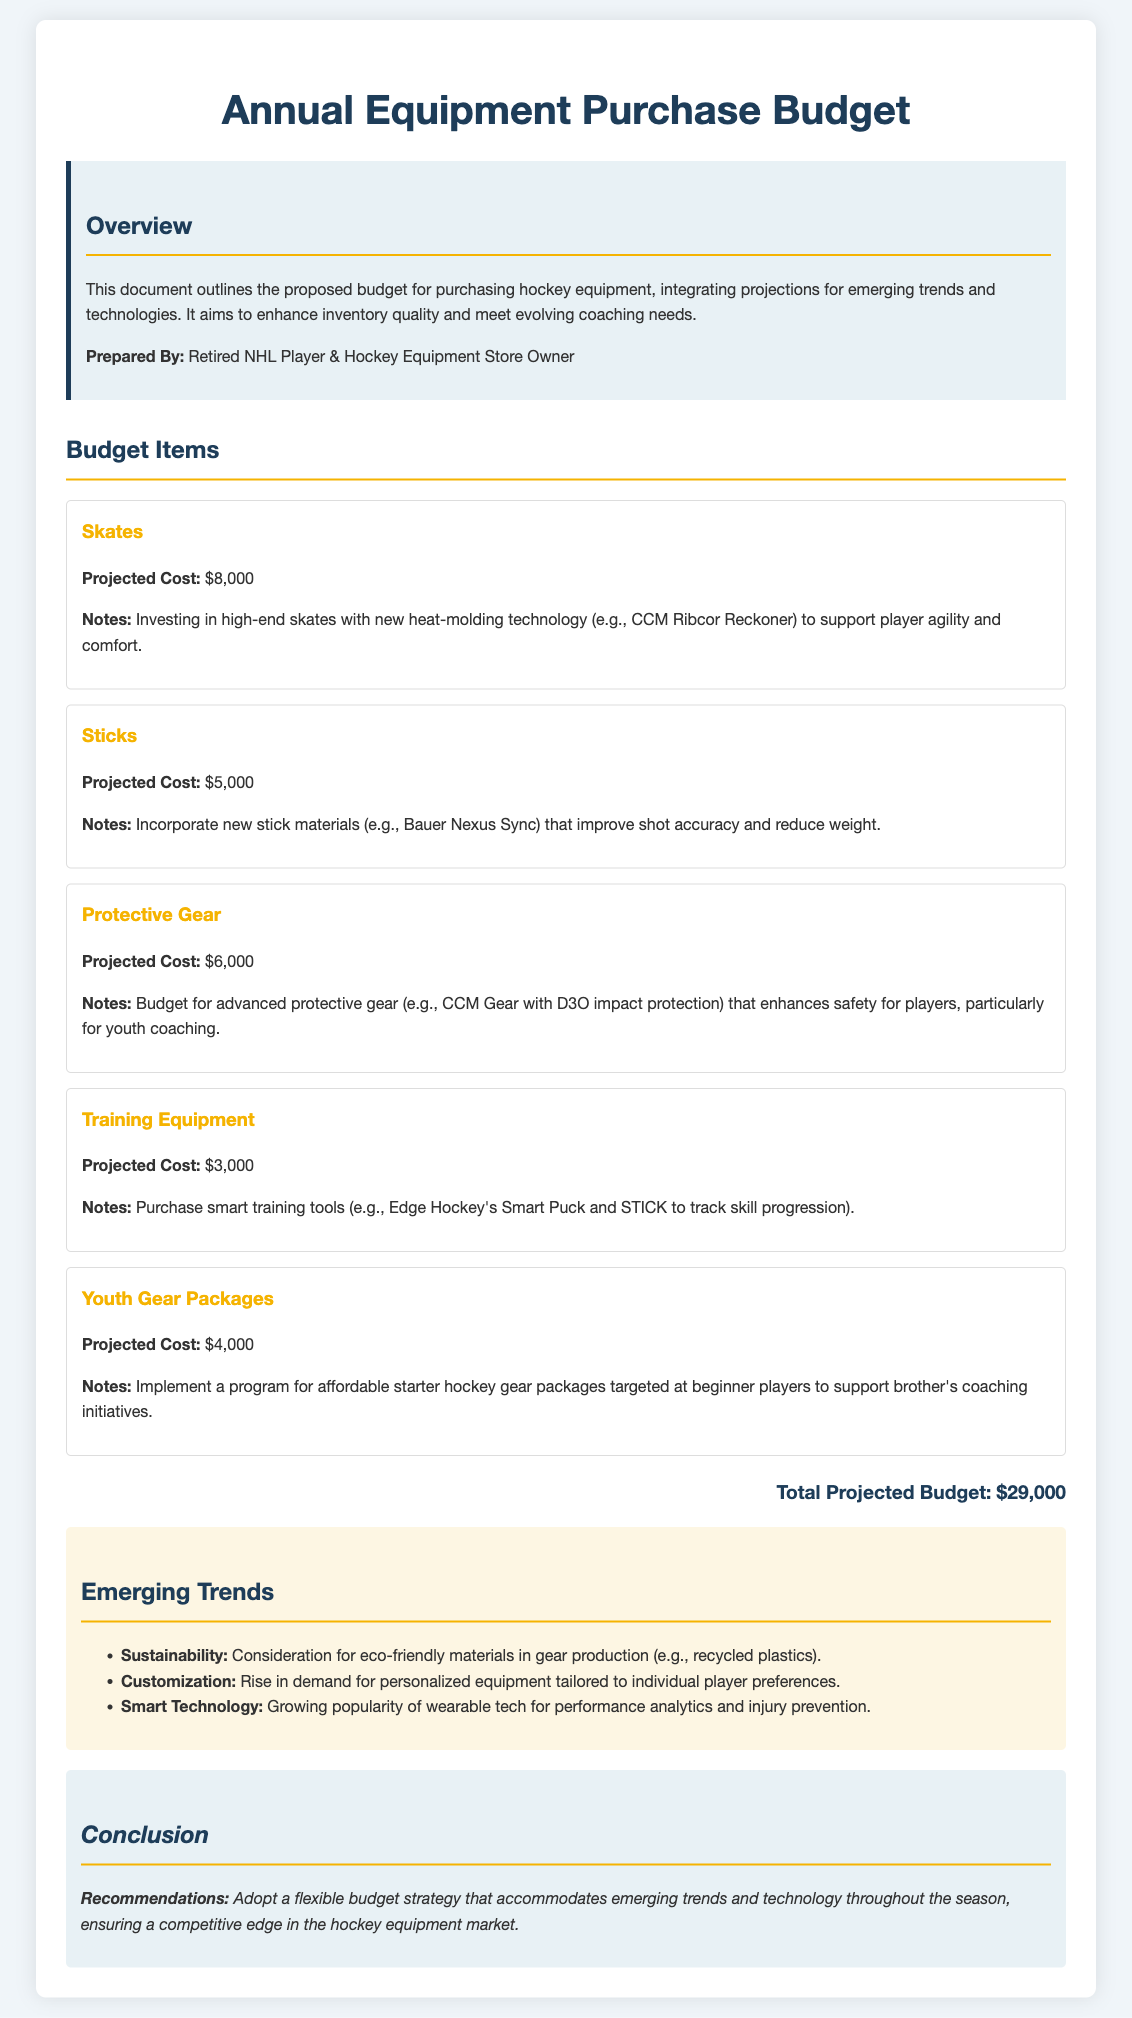What is the total projected budget? The total projected budget is provided at the end of the document, summing all costs of the budget items.
Answer: $29,000 What is the projected cost for skates? The projected cost for skates is listed under the budget items section.
Answer: $8,000 What technology is highlighted for skates? The document mentions a specific type of technology used in skates that enhances player agility and comfort.
Answer: Heat-molding technology Which protective gear feature improves safety? The document lists a specific feature of the protective gear that focuses on increased safety for players.
Answer: D3O impact protection What type of training equipment is mentioned? The document describes a specific training tool that aids in tracking skill progression.
Answer: Smart training tools How much is allocated for youth gear packages? The document specifies the budget set aside for youth gear packages.
Answer: $4,000 What emerging trend relates to materials? The document discusses a consideration for a trend affecting the production of hockey gear.
Answer: Sustainability Which stick is suggested for improving shot accuracy? The document names a specific stick that incorporates new materials.
Answer: Bauer Nexus Sync What recommendation is made regarding budget strategy? The conclusion section suggests a specific approach to budget management in light of trends.
Answer: Flexible budget strategy 